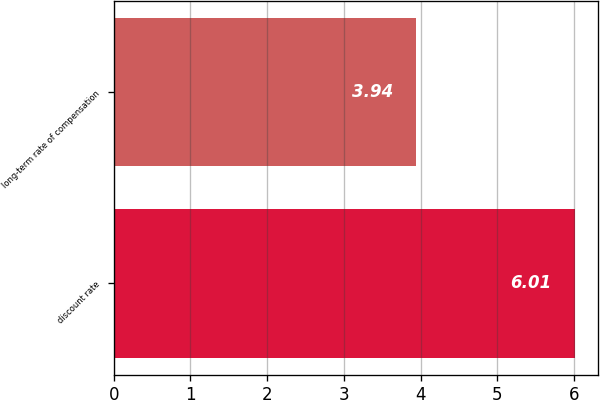<chart> <loc_0><loc_0><loc_500><loc_500><bar_chart><fcel>discount rate<fcel>long-term rate of compensation<nl><fcel>6.01<fcel>3.94<nl></chart> 